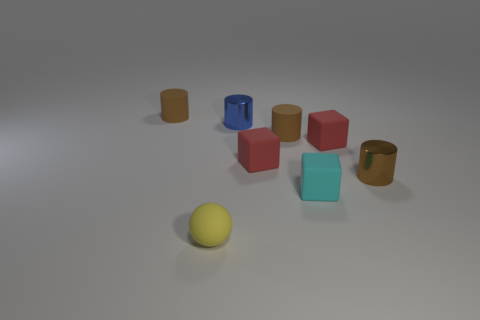Is the cube that is in front of the tiny brown metallic object made of the same material as the small brown cylinder that is on the left side of the sphere?
Your answer should be very brief. Yes. There is a brown object that is to the left of the small cyan block and on the right side of the tiny blue cylinder; what shape is it?
Offer a terse response. Cylinder. What number of tiny things are there?
Ensure brevity in your answer.  8. What size is the other metallic thing that is the same shape as the tiny blue metallic object?
Provide a short and direct response. Small. Does the tiny rubber thing in front of the small cyan matte cube have the same shape as the small blue object?
Provide a succinct answer. No. The tiny shiny cylinder that is to the left of the brown metallic thing is what color?
Keep it short and to the point. Blue. What number of other objects are there of the same size as the yellow matte ball?
Ensure brevity in your answer.  7. Are there any other things that are the same shape as the yellow thing?
Keep it short and to the point. No. Are there an equal number of small red matte cubes that are left of the yellow rubber ball and small green matte cylinders?
Your answer should be very brief. Yes. How many tiny brown things are the same material as the tiny yellow ball?
Keep it short and to the point. 2. 